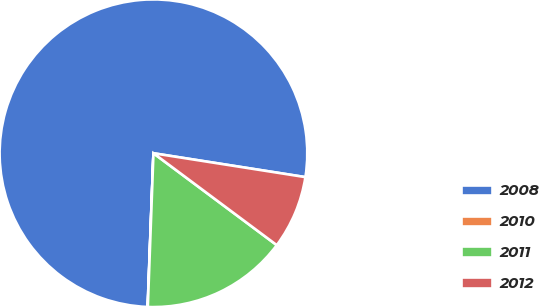Convert chart to OTSL. <chart><loc_0><loc_0><loc_500><loc_500><pie_chart><fcel>2008<fcel>2010<fcel>2011<fcel>2012<nl><fcel>76.87%<fcel>0.02%<fcel>15.39%<fcel>7.71%<nl></chart> 